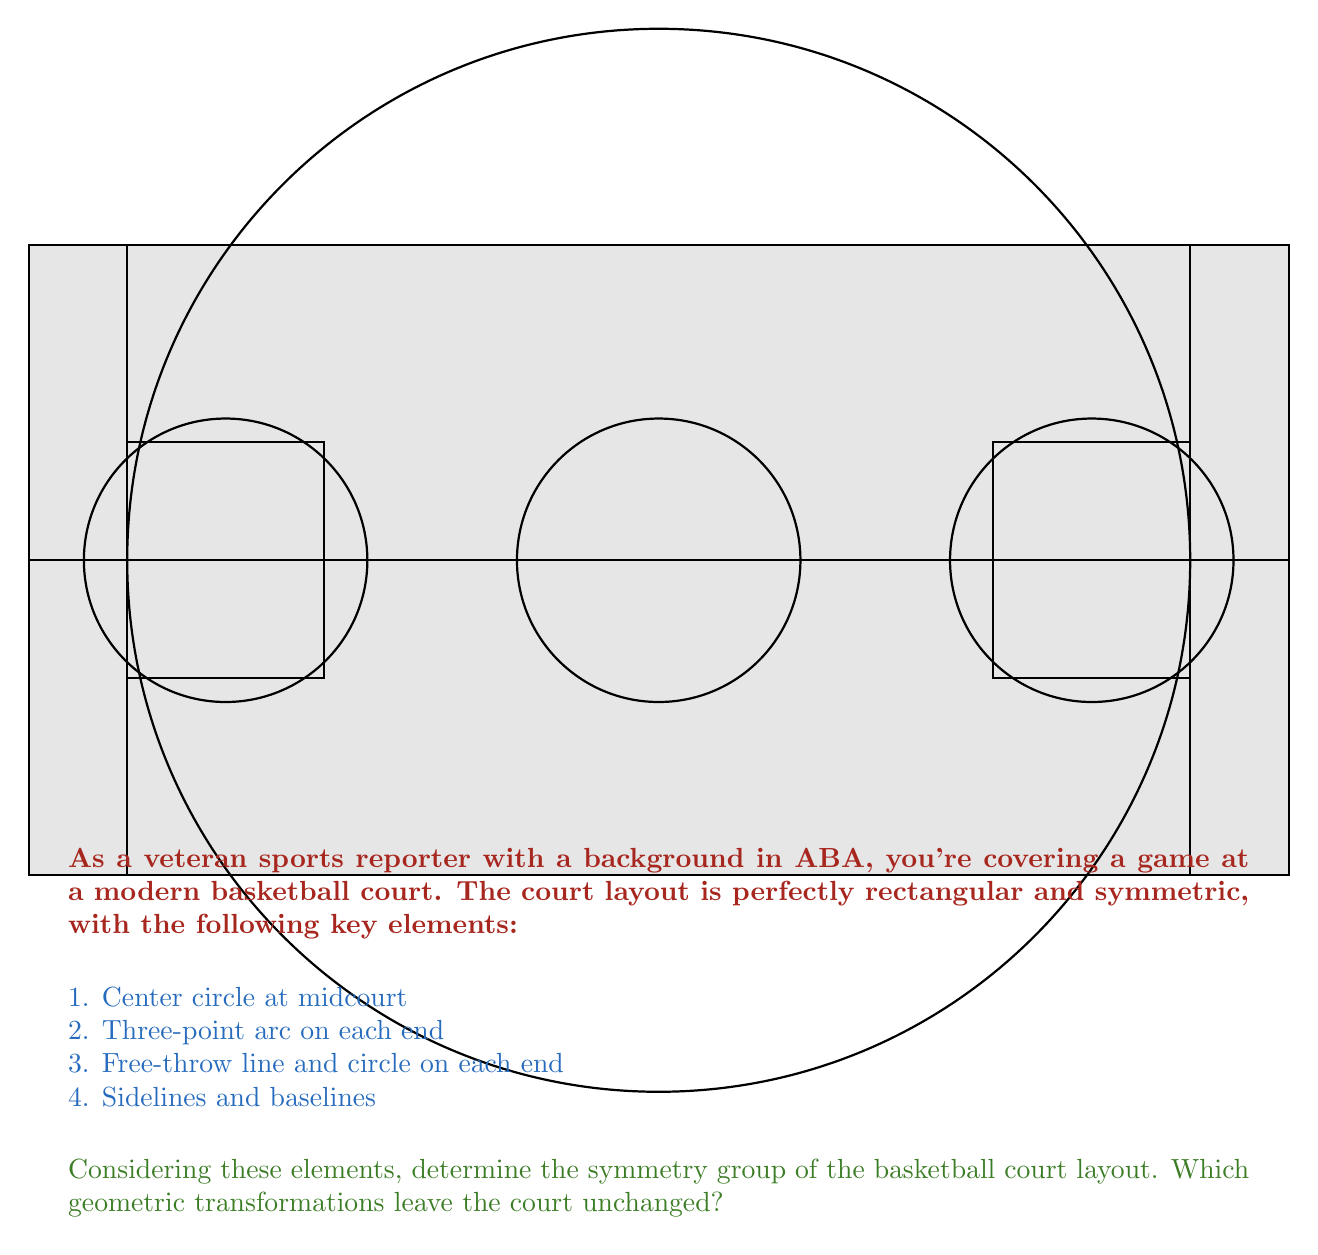Could you help me with this problem? To determine the symmetry group of the basketball court layout, we need to identify all the transformations that leave the court unchanged. Let's analyze the symmetries step-by-step:

1. Rotational symmetry:
   - The court has 180° rotational symmetry around its center point. A full 360° rotation also leaves it unchanged, but this is equivalent to the identity transformation.

2. Reflection symmetry:
   - The court has two lines of reflection:
     a) Along the center line (horizontal axis)
     b) Along the line perpendicular to the center line, passing through the center point (vertical axis)

3. Identity transformation:
   - Leaving the court as is, without any transformation, is always a symmetry.

These symmetries form a group under composition. Let's denote:
- $e$: identity transformation
- $r$: 180° rotation
- $h$: reflection across the horizontal axis
- $v$: reflection across the vertical axis

The group table for these transformations is:

$$
\begin{array}{c|cccc}
  & e & r & h & v \\
\hline
e & e & r & h & v \\
r & r & e & v & h \\
h & h & v & e & r \\
v & v & h & r & e
\end{array}
$$

This group structure is isomorphic to the Klein four-group, also known as $V_4$ or $C_2 \times C_2$. It is an abelian group of order 4, where every non-identity element has order 2.

The symmetry group of the basketball court layout is therefore isomorphic to the Klein four-group.
Answer: Klein four-group ($V_4$ or $C_2 \times C_2$) 